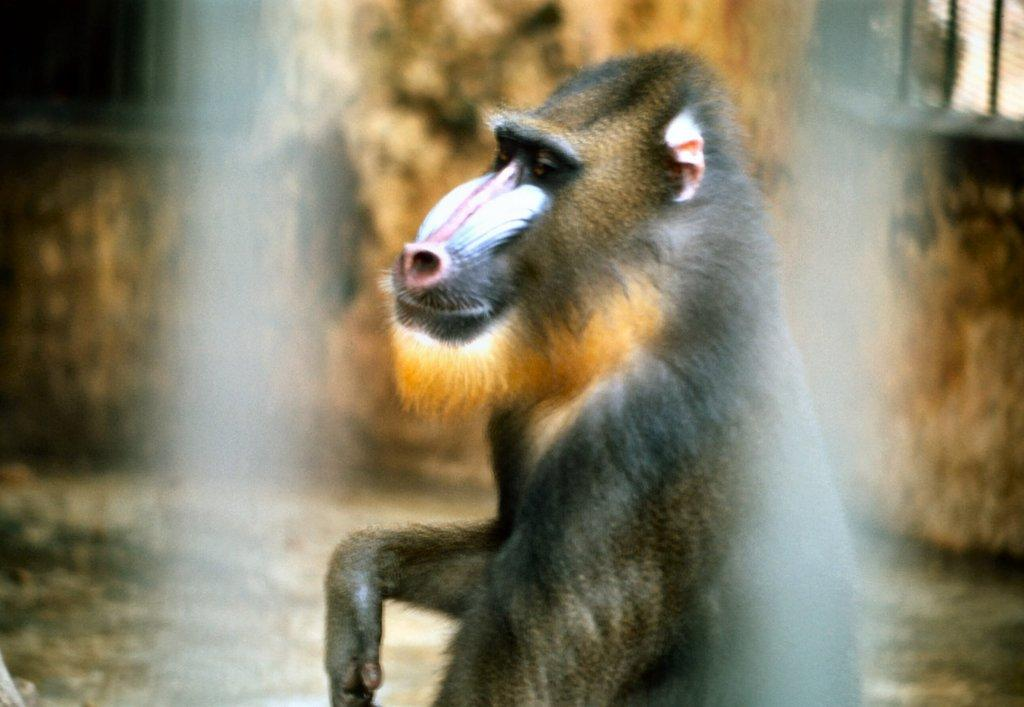What type of animal is in the image? There is an animal in the image, but the specific type cannot be determined from the provided facts. Can you describe the coloring of the animal? The animal has brown and cream coloring. What can be seen in the background of the image? There is a brown-colored wall and windows visible in the background of the image. How many rabbits are involved in the argument in the image? There is no argument or rabbits present in the image. Can you describe the type of fly that is buzzing around the animal in the image? There is no fly present in the image. 